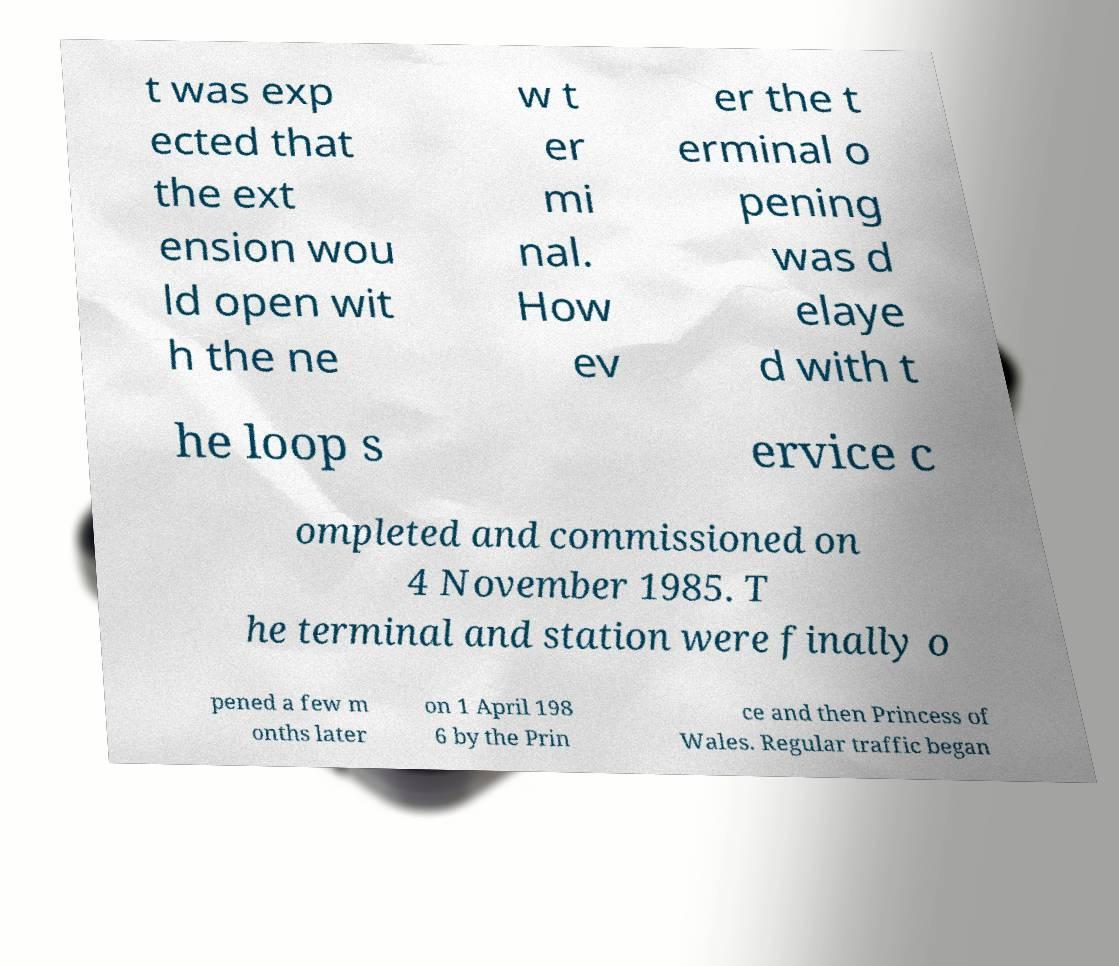Please read and relay the text visible in this image. What does it say? t was exp ected that the ext ension wou ld open wit h the ne w t er mi nal. How ev er the t erminal o pening was d elaye d with t he loop s ervice c ompleted and commissioned on 4 November 1985. T he terminal and station were finally o pened a few m onths later on 1 April 198 6 by the Prin ce and then Princess of Wales. Regular traffic began 